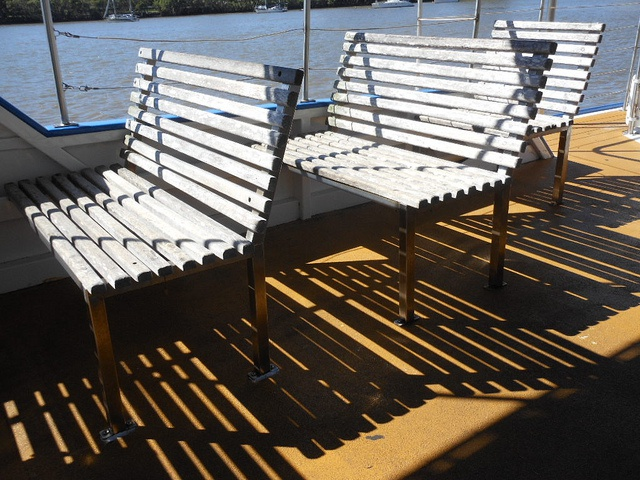Describe the objects in this image and their specific colors. I can see bench in black, white, gray, and darkgray tones, bench in black, white, gray, and darkgray tones, bench in black, white, darkgray, and gray tones, boat in black, gray, and darkgray tones, and boat in black, gray, and darkgray tones in this image. 